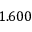<formula> <loc_0><loc_0><loc_500><loc_500>1 . 6 0 0</formula> 